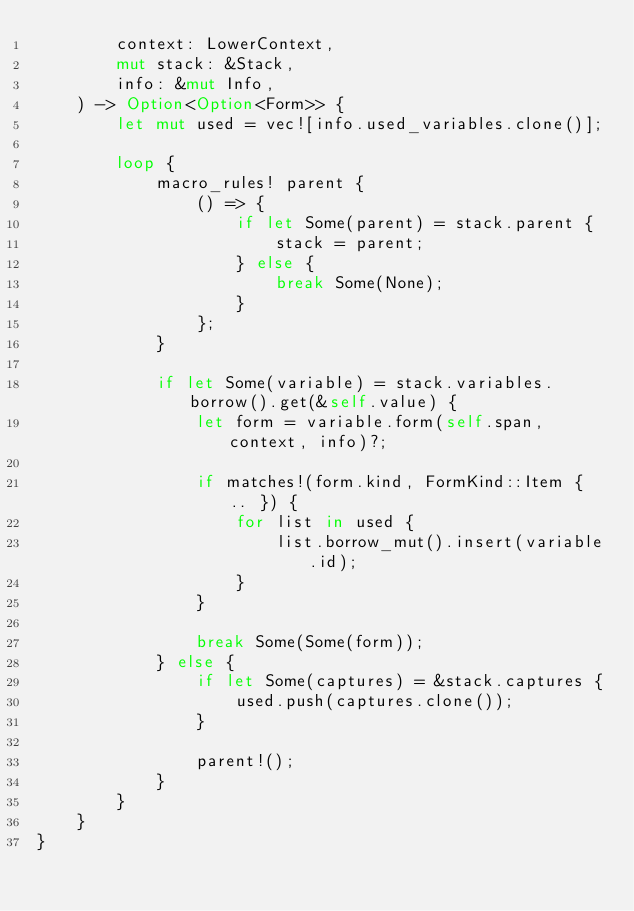Convert code to text. <code><loc_0><loc_0><loc_500><loc_500><_Rust_>        context: LowerContext,
        mut stack: &Stack,
        info: &mut Info,
    ) -> Option<Option<Form>> {
        let mut used = vec![info.used_variables.clone()];

        loop {
            macro_rules! parent {
                () => {
                    if let Some(parent) = stack.parent {
                        stack = parent;
                    } else {
                        break Some(None);
                    }
                };
            }

            if let Some(variable) = stack.variables.borrow().get(&self.value) {
                let form = variable.form(self.span, context, info)?;

                if matches!(form.kind, FormKind::Item { .. }) {
                    for list in used {
                        list.borrow_mut().insert(variable.id);
                    }
                }

                break Some(Some(form));
            } else {
                if let Some(captures) = &stack.captures {
                    used.push(captures.clone());
                }

                parent!();
            }
        }
    }
}
</code> 